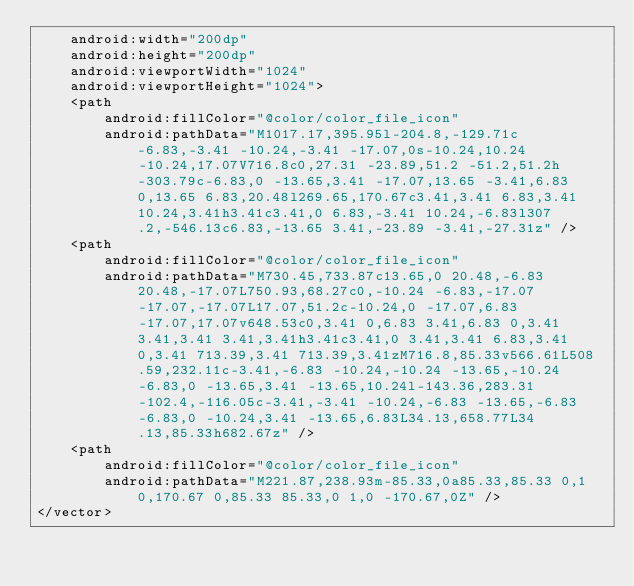<code> <loc_0><loc_0><loc_500><loc_500><_XML_>    android:width="200dp"
    android:height="200dp"
    android:viewportWidth="1024"
    android:viewportHeight="1024">
    <path
        android:fillColor="@color/color_file_icon"
        android:pathData="M1017.17,395.95l-204.8,-129.71c-6.83,-3.41 -10.24,-3.41 -17.07,0s-10.24,10.24 -10.24,17.07V716.8c0,27.31 -23.89,51.2 -51.2,51.2h-303.79c-6.83,0 -13.65,3.41 -17.07,13.65 -3.41,6.83 0,13.65 6.83,20.48l269.65,170.67c3.41,3.41 6.83,3.41 10.24,3.41h3.41c3.41,0 6.83,-3.41 10.24,-6.83l307.2,-546.13c6.83,-13.65 3.41,-23.89 -3.41,-27.31z" />
    <path
        android:fillColor="@color/color_file_icon"
        android:pathData="M730.45,733.87c13.65,0 20.48,-6.83 20.48,-17.07L750.93,68.27c0,-10.24 -6.83,-17.07 -17.07,-17.07L17.07,51.2c-10.24,0 -17.07,6.83 -17.07,17.07v648.53c0,3.41 0,6.83 3.41,6.83 0,3.41 3.41,3.41 3.41,3.41h3.41c3.41,0 3.41,3.41 6.83,3.41 0,3.41 713.39,3.41 713.39,3.41zM716.8,85.33v566.61L508.59,232.11c-3.41,-6.83 -10.24,-10.24 -13.65,-10.24 -6.83,0 -13.65,3.41 -13.65,10.24l-143.36,283.31 -102.4,-116.05c-3.41,-3.41 -10.24,-6.83 -13.65,-6.83 -6.83,0 -10.24,3.41 -13.65,6.83L34.13,658.77L34.13,85.33h682.67z" />
    <path
        android:fillColor="@color/color_file_icon"
        android:pathData="M221.87,238.93m-85.33,0a85.33,85.33 0,1 0,170.67 0,85.33 85.33,0 1,0 -170.67,0Z" />
</vector>
</code> 